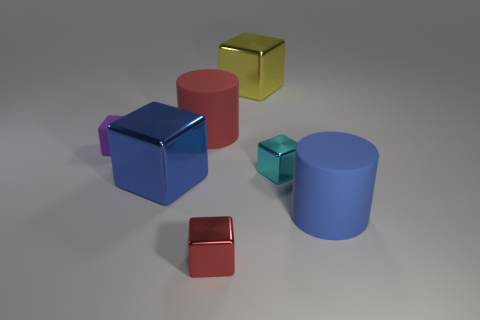There is a large metal thing in front of the big yellow cube; does it have the same color as the large cylinder in front of the blue shiny block?
Your answer should be very brief. Yes. What color is the small thing right of the metallic object in front of the blue object to the left of the cyan thing?
Make the answer very short. Cyan. Are there fewer large shiny blocks behind the tiny cyan object than red things?
Provide a succinct answer. Yes. Do the rubber thing in front of the purple matte thing and the tiny red metallic object that is in front of the small matte cube have the same shape?
Offer a terse response. No. How many objects are cubes that are behind the red shiny block or large yellow metallic blocks?
Provide a succinct answer. 4. There is a metal block that is behind the big rubber thing behind the small rubber cube; are there any cyan things that are on the left side of it?
Your answer should be compact. No. Is the number of big blue rubber cylinders that are in front of the small red object less than the number of small purple rubber objects that are left of the red matte cylinder?
Give a very brief answer. Yes. What is the color of the other small block that is made of the same material as the cyan cube?
Make the answer very short. Red. What color is the cylinder that is left of the red metal block that is in front of the big blue metal block?
Offer a terse response. Red. Is there another tiny object of the same color as the small rubber thing?
Your response must be concise. No. 